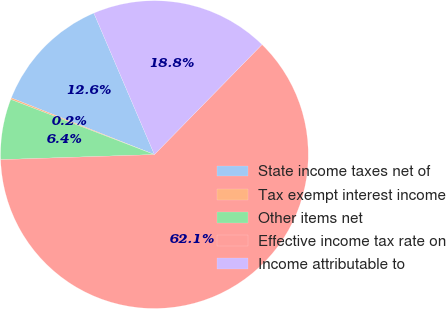<chart> <loc_0><loc_0><loc_500><loc_500><pie_chart><fcel>State income taxes net of<fcel>Tax exempt interest income<fcel>Other items net<fcel>Effective income tax rate on<fcel>Income attributable to<nl><fcel>12.56%<fcel>0.17%<fcel>6.36%<fcel>62.15%<fcel>18.76%<nl></chart> 